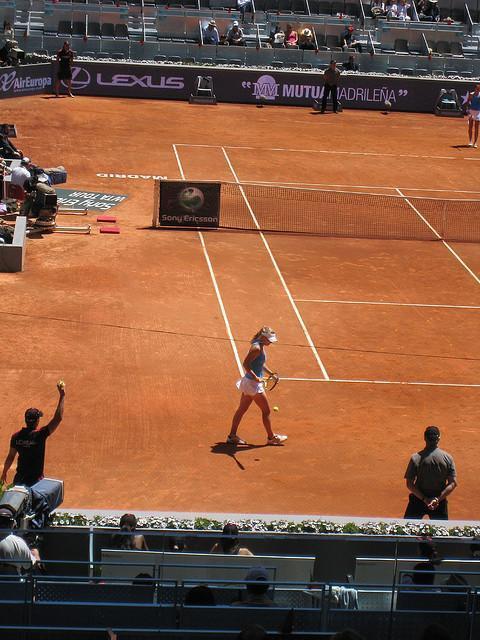How many people are visible?
Give a very brief answer. 3. How many benches can be seen?
Give a very brief answer. 2. How many dark brown sheep are in the image?
Give a very brief answer. 0. 